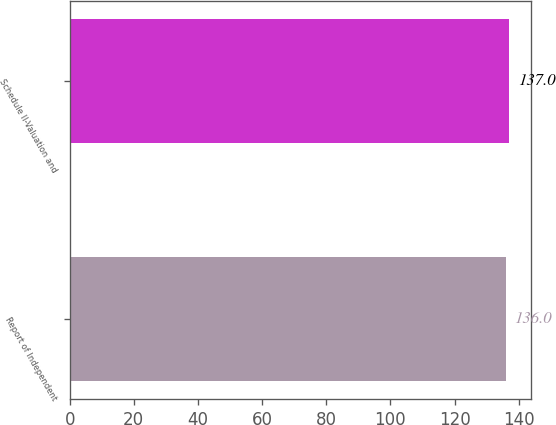Convert chart to OTSL. <chart><loc_0><loc_0><loc_500><loc_500><bar_chart><fcel>Report of Independent<fcel>Schedule II-Valuation and<nl><fcel>136<fcel>137<nl></chart> 